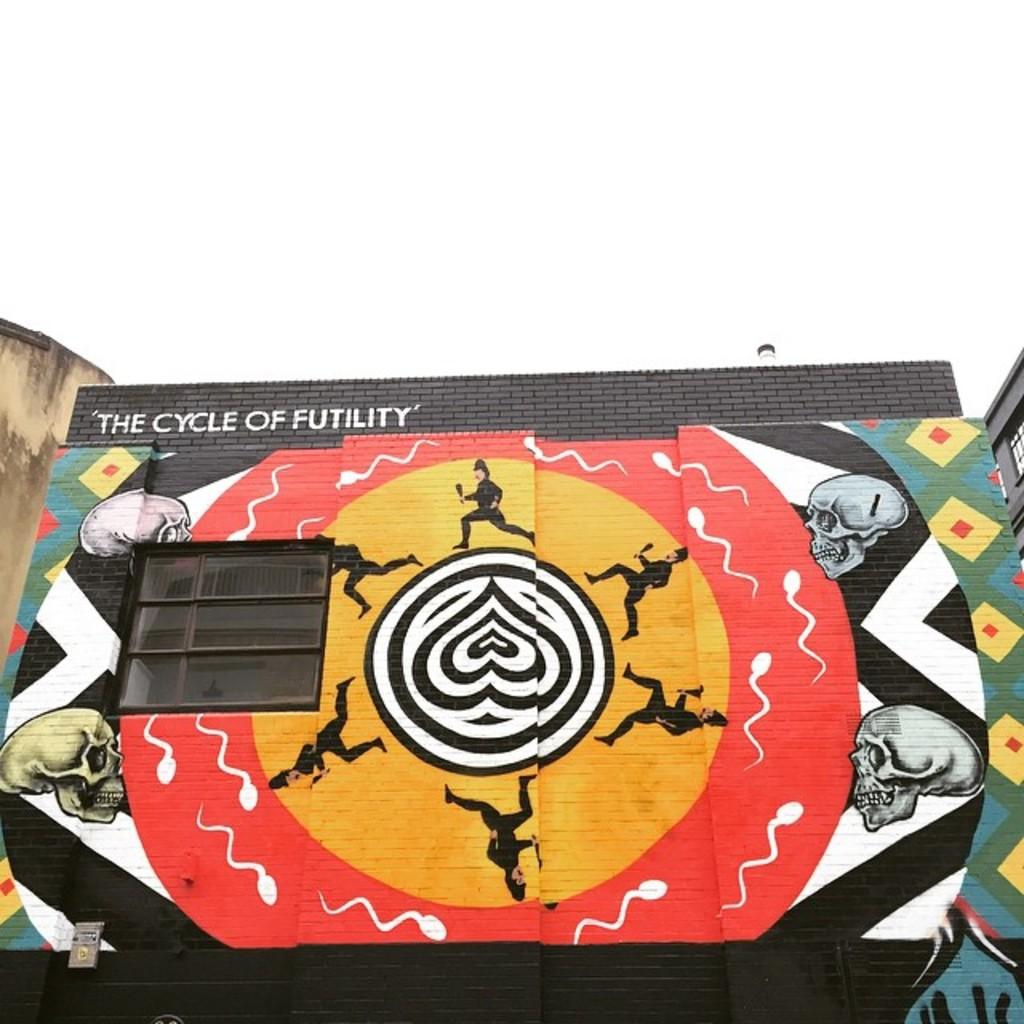What is visible at the top of the image? The sky is visible at the top of the image. What type of structure can be seen in the image? There is a building in the image. What feature of the building is mentioned in the facts? There is a window and a painting on the building. Is there any text present on the building? Yes, there is text on the building. What time of day is it in the image, considering the presence of giants and a frog? There are no giants or frogs present in the image, so it is not possible to determine the time of day based on their presence. 